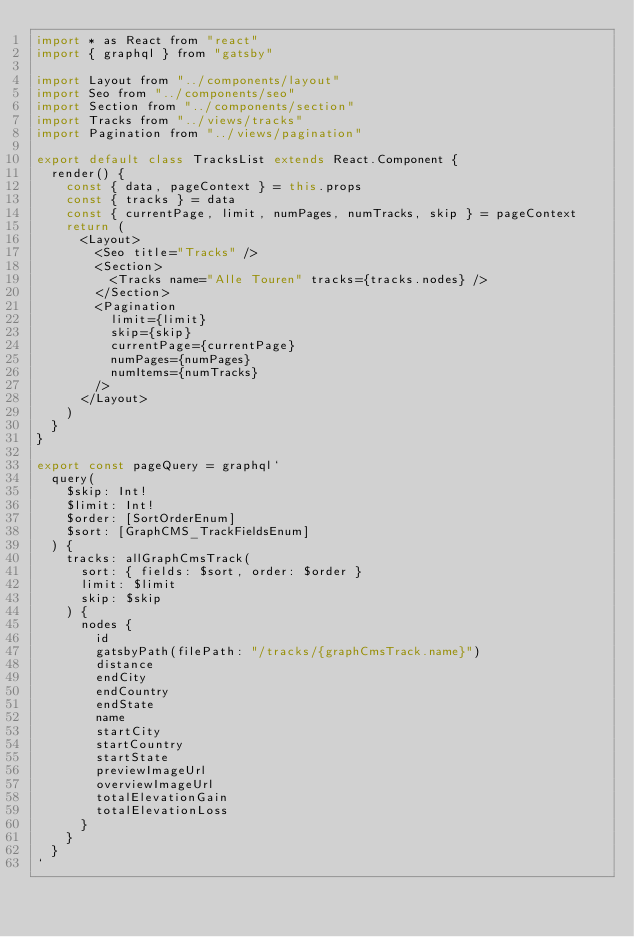<code> <loc_0><loc_0><loc_500><loc_500><_JavaScript_>import * as React from "react"
import { graphql } from "gatsby"

import Layout from "../components/layout"
import Seo from "../components/seo"
import Section from "../components/section"
import Tracks from "../views/tracks"
import Pagination from "../views/pagination"

export default class TracksList extends React.Component {
  render() {
    const { data, pageContext } = this.props
    const { tracks } = data
    const { currentPage, limit, numPages, numTracks, skip } = pageContext
    return (
      <Layout>
        <Seo title="Tracks" />
        <Section>
          <Tracks name="Alle Touren" tracks={tracks.nodes} />
        </Section>
        <Pagination
          limit={limit}
          skip={skip}
          currentPage={currentPage}
          numPages={numPages}
          numItems={numTracks}
        />
      </Layout>
    )
  }
}

export const pageQuery = graphql`
  query(
    $skip: Int!
    $limit: Int!
    $order: [SortOrderEnum]
    $sort: [GraphCMS_TrackFieldsEnum]
  ) {
    tracks: allGraphCmsTrack(
      sort: { fields: $sort, order: $order }
      limit: $limit
      skip: $skip
    ) {
      nodes {
        id
        gatsbyPath(filePath: "/tracks/{graphCmsTrack.name}")
        distance
        endCity
        endCountry
        endState
        name
        startCity
        startCountry
        startState
        previewImageUrl
        overviewImageUrl
        totalElevationGain
        totalElevationLoss
      }
    }
  }
`
</code> 